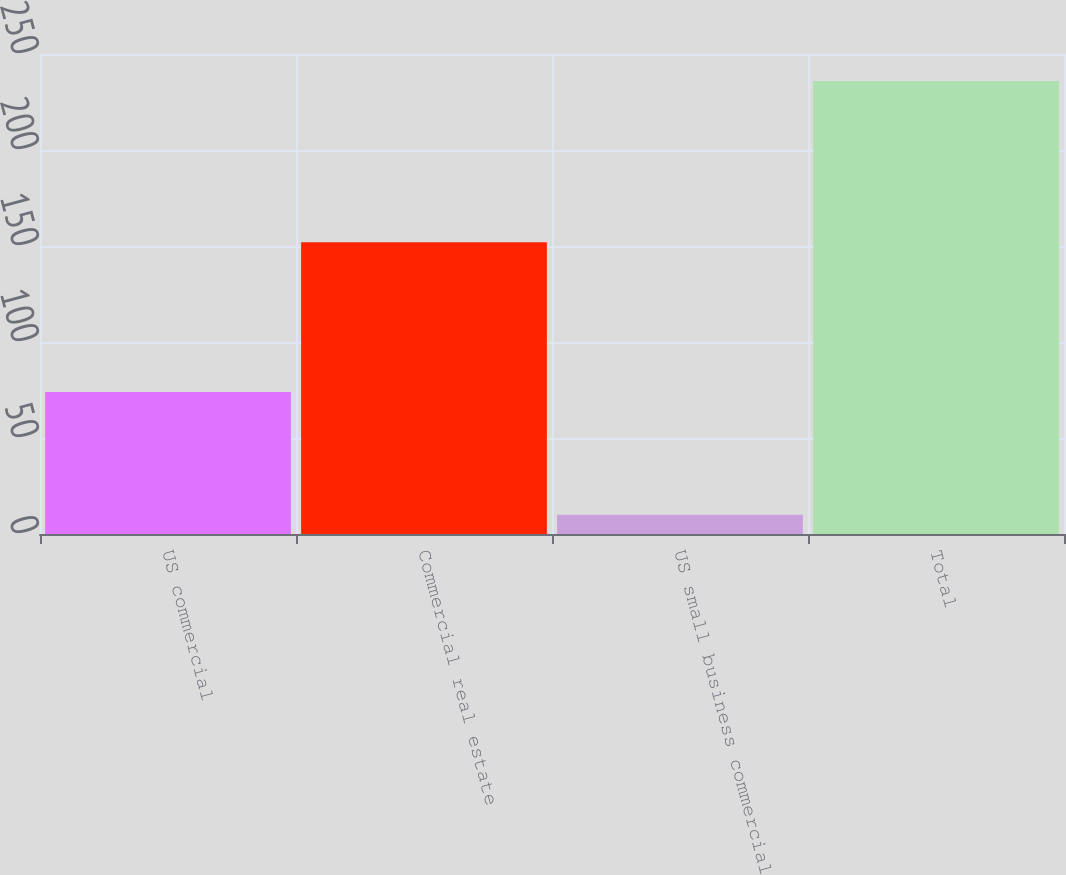Convert chart. <chart><loc_0><loc_0><loc_500><loc_500><bar_chart><fcel>US commercial<fcel>Commercial real estate<fcel>US small business commercial<fcel>Total<nl><fcel>74<fcel>152<fcel>10<fcel>236<nl></chart> 